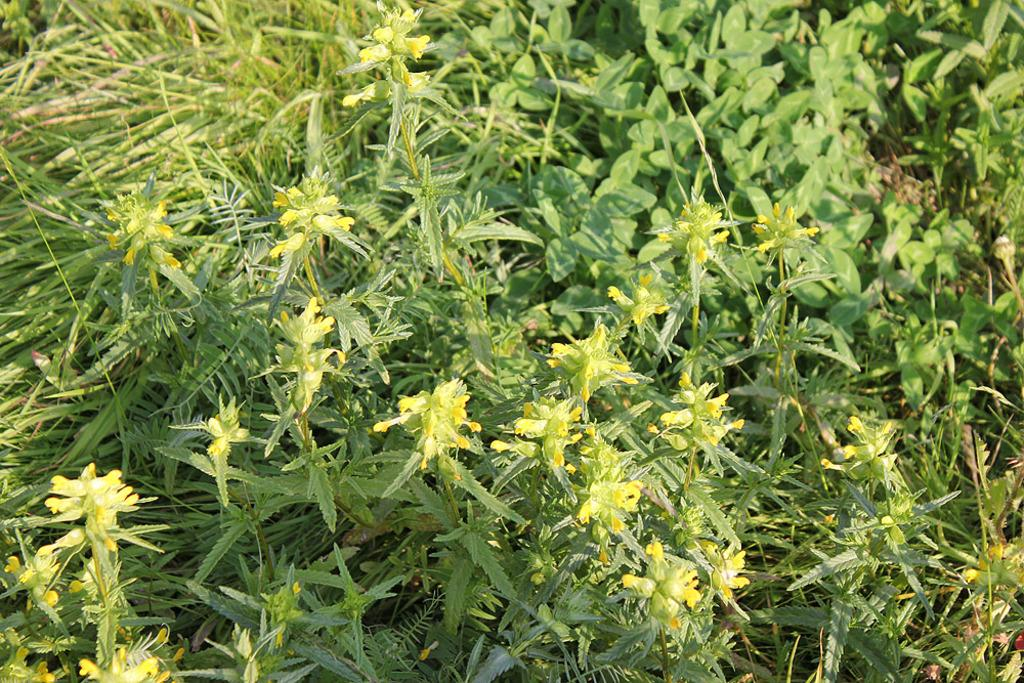What type of plants can be seen in the image? There are flowering plants in the image. What color is the grass in the image? The grass in the image is green. What type of muscle can be seen flexing in the image? There is no muscle present in the image; it features flowering plants and green grass. What color is the orange in the image? There is no orange present in the image. 